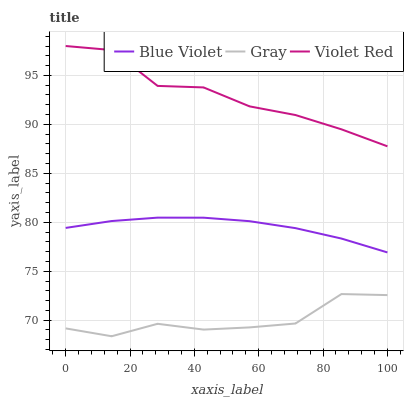Does Gray have the minimum area under the curve?
Answer yes or no. Yes. Does Violet Red have the maximum area under the curve?
Answer yes or no. Yes. Does Blue Violet have the minimum area under the curve?
Answer yes or no. No. Does Blue Violet have the maximum area under the curve?
Answer yes or no. No. Is Blue Violet the smoothest?
Answer yes or no. Yes. Is Gray the roughest?
Answer yes or no. Yes. Is Violet Red the smoothest?
Answer yes or no. No. Is Violet Red the roughest?
Answer yes or no. No. Does Gray have the lowest value?
Answer yes or no. Yes. Does Blue Violet have the lowest value?
Answer yes or no. No. Does Violet Red have the highest value?
Answer yes or no. Yes. Does Blue Violet have the highest value?
Answer yes or no. No. Is Gray less than Blue Violet?
Answer yes or no. Yes. Is Blue Violet greater than Gray?
Answer yes or no. Yes. Does Gray intersect Blue Violet?
Answer yes or no. No. 